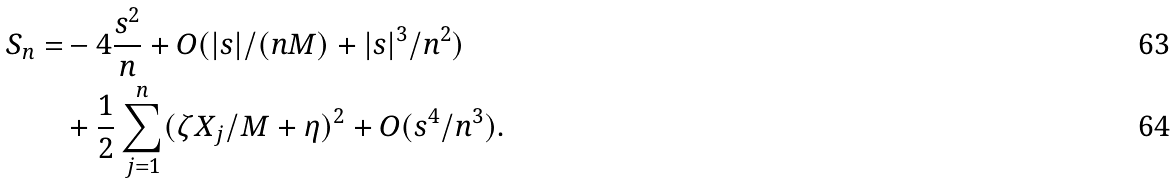Convert formula to latex. <formula><loc_0><loc_0><loc_500><loc_500>S _ { n } = & - 4 \frac { s ^ { 2 } } { n } + O ( | s | / ( n M ) + | s | ^ { 3 } / n ^ { 2 } ) \\ & + \frac { 1 } { 2 } \sum _ { j = 1 } ^ { n } ( \zeta X _ { j } / M + \eta ) ^ { 2 } + O ( s ^ { 4 } / n ^ { 3 } ) .</formula> 